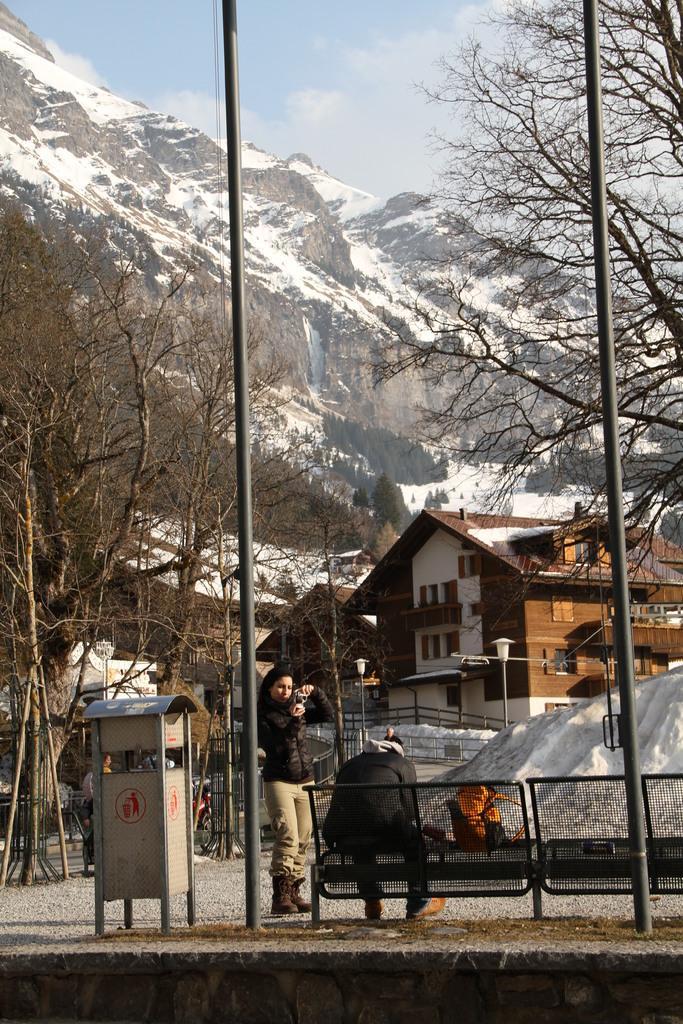Could you give a brief overview of what you see in this image? In this image there is a person sitting on a bench. Beside the bench there is a woman standing and she is holding a camera in her hand. Behind the bench there are poles. In front of the bench there are houses, trees and street light poles. In the background there are mountains. There is snow on the mountains. At the top there is the sky. 